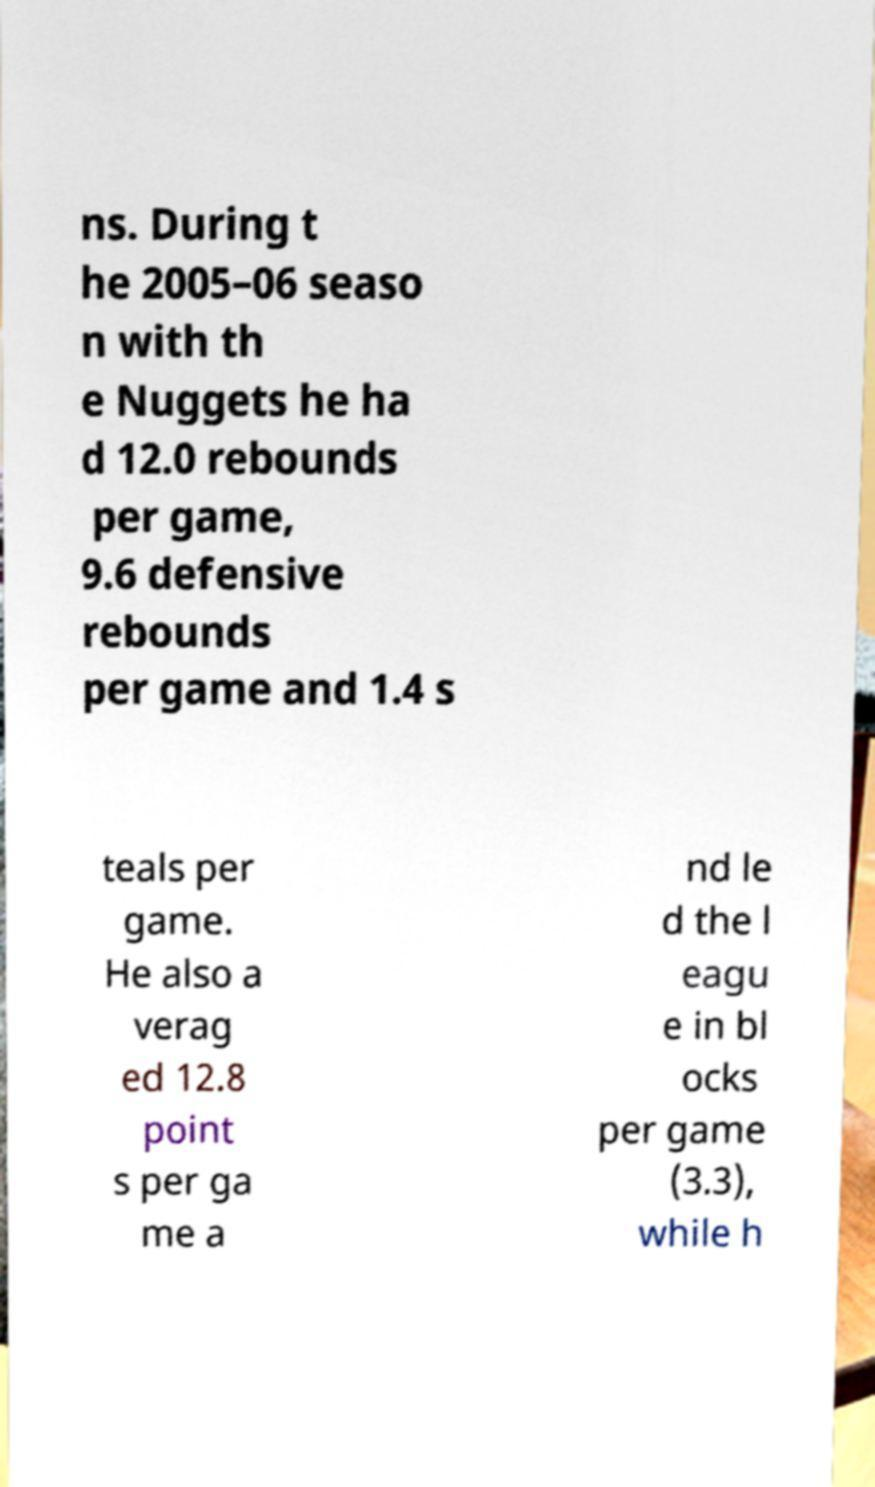For documentation purposes, I need the text within this image transcribed. Could you provide that? ns. During t he 2005–06 seaso n with th e Nuggets he ha d 12.0 rebounds per game, 9.6 defensive rebounds per game and 1.4 s teals per game. He also a verag ed 12.8 point s per ga me a nd le d the l eagu e in bl ocks per game (3.3), while h 